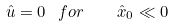Convert formula to latex. <formula><loc_0><loc_0><loc_500><loc_500>\hat { u } = 0 \ \ f o r \quad \hat { x } _ { 0 } \ll 0</formula> 